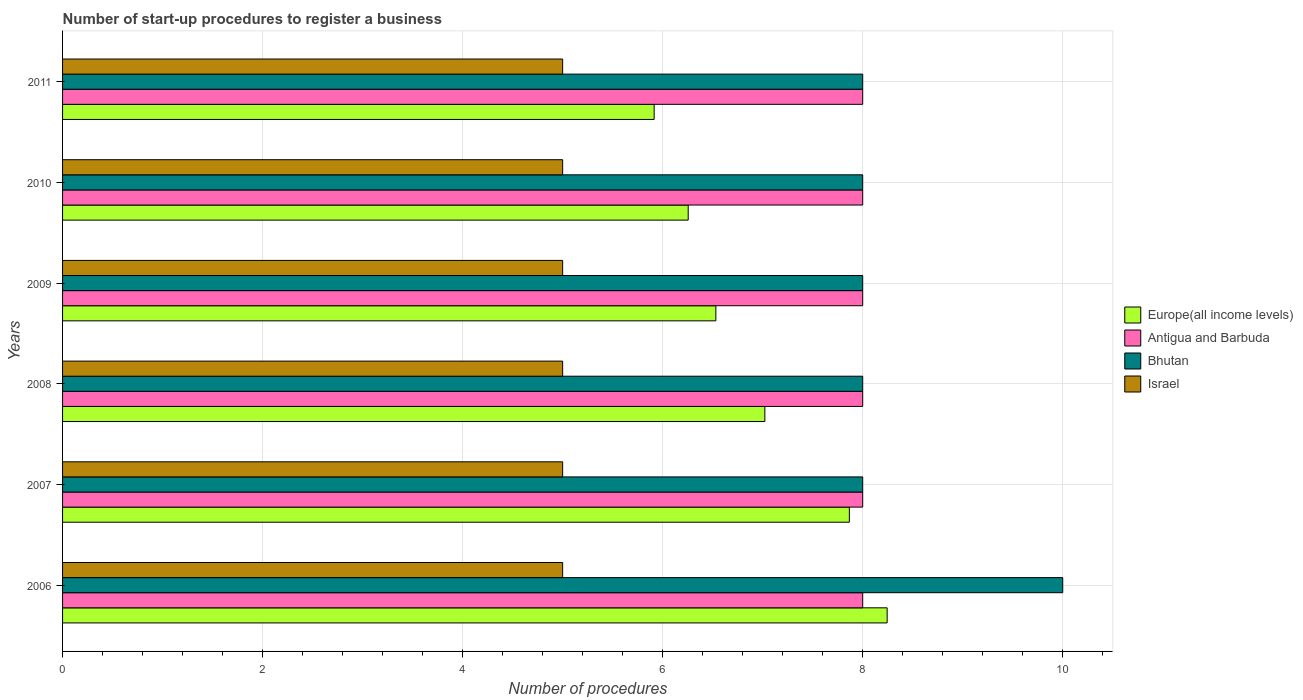How many different coloured bars are there?
Offer a very short reply. 4. How many groups of bars are there?
Your response must be concise. 6. Are the number of bars per tick equal to the number of legend labels?
Keep it short and to the point. Yes. Are the number of bars on each tick of the Y-axis equal?
Offer a terse response. Yes. What is the label of the 4th group of bars from the top?
Provide a succinct answer. 2008. What is the number of procedures required to register a business in Europe(all income levels) in 2011?
Your answer should be very brief. 5.91. Across all years, what is the maximum number of procedures required to register a business in Israel?
Provide a short and direct response. 5. Across all years, what is the minimum number of procedures required to register a business in Bhutan?
Provide a succinct answer. 8. In which year was the number of procedures required to register a business in Israel maximum?
Provide a succinct answer. 2006. What is the total number of procedures required to register a business in Antigua and Barbuda in the graph?
Keep it short and to the point. 48. What is the difference between the number of procedures required to register a business in Bhutan in 2006 and that in 2011?
Your response must be concise. 2. What is the difference between the number of procedures required to register a business in Israel in 2009 and the number of procedures required to register a business in Antigua and Barbuda in 2011?
Offer a very short reply. -3. What is the average number of procedures required to register a business in Antigua and Barbuda per year?
Keep it short and to the point. 8. In the year 2007, what is the difference between the number of procedures required to register a business in Europe(all income levels) and number of procedures required to register a business in Israel?
Ensure brevity in your answer.  2.87. In how many years, is the number of procedures required to register a business in Bhutan greater than 6 ?
Your answer should be very brief. 6. What is the ratio of the number of procedures required to register a business in Bhutan in 2007 to that in 2008?
Keep it short and to the point. 1. Is the number of procedures required to register a business in Antigua and Barbuda in 2007 less than that in 2008?
Your answer should be very brief. No. What is the difference between the highest and the lowest number of procedures required to register a business in Israel?
Offer a terse response. 0. Is the sum of the number of procedures required to register a business in Bhutan in 2010 and 2011 greater than the maximum number of procedures required to register a business in Europe(all income levels) across all years?
Your answer should be compact. Yes. Is it the case that in every year, the sum of the number of procedures required to register a business in Bhutan and number of procedures required to register a business in Israel is greater than the sum of number of procedures required to register a business in Europe(all income levels) and number of procedures required to register a business in Antigua and Barbuda?
Keep it short and to the point. Yes. What does the 4th bar from the top in 2009 represents?
Your answer should be very brief. Europe(all income levels). What does the 4th bar from the bottom in 2007 represents?
Provide a succinct answer. Israel. Is it the case that in every year, the sum of the number of procedures required to register a business in Europe(all income levels) and number of procedures required to register a business in Antigua and Barbuda is greater than the number of procedures required to register a business in Israel?
Give a very brief answer. Yes. How many bars are there?
Offer a very short reply. 24. Are all the bars in the graph horizontal?
Your answer should be very brief. Yes. Are the values on the major ticks of X-axis written in scientific E-notation?
Keep it short and to the point. No. Does the graph contain grids?
Make the answer very short. Yes. How many legend labels are there?
Offer a terse response. 4. How are the legend labels stacked?
Your response must be concise. Vertical. What is the title of the graph?
Provide a succinct answer. Number of start-up procedures to register a business. What is the label or title of the X-axis?
Make the answer very short. Number of procedures. What is the Number of procedures in Europe(all income levels) in 2006?
Your response must be concise. 8.24. What is the Number of procedures in Antigua and Barbuda in 2006?
Your answer should be compact. 8. What is the Number of procedures of Bhutan in 2006?
Offer a terse response. 10. What is the Number of procedures of Europe(all income levels) in 2007?
Give a very brief answer. 7.87. What is the Number of procedures of Antigua and Barbuda in 2007?
Make the answer very short. 8. What is the Number of procedures in Bhutan in 2007?
Offer a very short reply. 8. What is the Number of procedures of Europe(all income levels) in 2008?
Your answer should be very brief. 7.02. What is the Number of procedures in Antigua and Barbuda in 2008?
Provide a short and direct response. 8. What is the Number of procedures in Bhutan in 2008?
Ensure brevity in your answer.  8. What is the Number of procedures of Israel in 2008?
Your answer should be very brief. 5. What is the Number of procedures of Europe(all income levels) in 2009?
Ensure brevity in your answer.  6.53. What is the Number of procedures in Europe(all income levels) in 2010?
Your answer should be compact. 6.26. What is the Number of procedures of Antigua and Barbuda in 2010?
Your answer should be very brief. 8. What is the Number of procedures of Europe(all income levels) in 2011?
Provide a succinct answer. 5.91. What is the Number of procedures in Antigua and Barbuda in 2011?
Offer a terse response. 8. What is the Number of procedures in Israel in 2011?
Offer a terse response. 5. Across all years, what is the maximum Number of procedures in Europe(all income levels)?
Provide a short and direct response. 8.24. Across all years, what is the minimum Number of procedures in Europe(all income levels)?
Provide a succinct answer. 5.91. Across all years, what is the minimum Number of procedures of Bhutan?
Your answer should be compact. 8. What is the total Number of procedures of Europe(all income levels) in the graph?
Make the answer very short. 41.84. What is the total Number of procedures in Antigua and Barbuda in the graph?
Offer a terse response. 48. What is the total Number of procedures of Bhutan in the graph?
Give a very brief answer. 50. What is the total Number of procedures of Israel in the graph?
Offer a very short reply. 30. What is the difference between the Number of procedures in Europe(all income levels) in 2006 and that in 2007?
Offer a terse response. 0.38. What is the difference between the Number of procedures in Antigua and Barbuda in 2006 and that in 2007?
Make the answer very short. 0. What is the difference between the Number of procedures in Israel in 2006 and that in 2007?
Offer a terse response. 0. What is the difference between the Number of procedures of Europe(all income levels) in 2006 and that in 2008?
Your response must be concise. 1.22. What is the difference between the Number of procedures of Antigua and Barbuda in 2006 and that in 2008?
Provide a succinct answer. 0. What is the difference between the Number of procedures of Bhutan in 2006 and that in 2008?
Ensure brevity in your answer.  2. What is the difference between the Number of procedures of Israel in 2006 and that in 2008?
Keep it short and to the point. 0. What is the difference between the Number of procedures of Europe(all income levels) in 2006 and that in 2009?
Provide a short and direct response. 1.71. What is the difference between the Number of procedures of Europe(all income levels) in 2006 and that in 2010?
Ensure brevity in your answer.  1.99. What is the difference between the Number of procedures in Antigua and Barbuda in 2006 and that in 2010?
Keep it short and to the point. 0. What is the difference between the Number of procedures of Israel in 2006 and that in 2010?
Your answer should be very brief. 0. What is the difference between the Number of procedures of Europe(all income levels) in 2006 and that in 2011?
Provide a succinct answer. 2.33. What is the difference between the Number of procedures of Antigua and Barbuda in 2006 and that in 2011?
Your response must be concise. 0. What is the difference between the Number of procedures in Israel in 2006 and that in 2011?
Provide a short and direct response. 0. What is the difference between the Number of procedures in Europe(all income levels) in 2007 and that in 2008?
Give a very brief answer. 0.84. What is the difference between the Number of procedures in Antigua and Barbuda in 2007 and that in 2008?
Offer a terse response. 0. What is the difference between the Number of procedures in Bhutan in 2007 and that in 2008?
Provide a short and direct response. 0. What is the difference between the Number of procedures in Europe(all income levels) in 2007 and that in 2009?
Provide a succinct answer. 1.33. What is the difference between the Number of procedures in Antigua and Barbuda in 2007 and that in 2009?
Make the answer very short. 0. What is the difference between the Number of procedures of Bhutan in 2007 and that in 2009?
Your response must be concise. 0. What is the difference between the Number of procedures of Israel in 2007 and that in 2009?
Provide a short and direct response. 0. What is the difference between the Number of procedures of Europe(all income levels) in 2007 and that in 2010?
Your answer should be very brief. 1.61. What is the difference between the Number of procedures in Antigua and Barbuda in 2007 and that in 2010?
Your answer should be very brief. 0. What is the difference between the Number of procedures in Israel in 2007 and that in 2010?
Your answer should be very brief. 0. What is the difference between the Number of procedures of Europe(all income levels) in 2007 and that in 2011?
Your response must be concise. 1.95. What is the difference between the Number of procedures in Antigua and Barbuda in 2007 and that in 2011?
Keep it short and to the point. 0. What is the difference between the Number of procedures of Bhutan in 2007 and that in 2011?
Make the answer very short. 0. What is the difference between the Number of procedures in Europe(all income levels) in 2008 and that in 2009?
Keep it short and to the point. 0.49. What is the difference between the Number of procedures in Israel in 2008 and that in 2009?
Offer a very short reply. 0. What is the difference between the Number of procedures in Europe(all income levels) in 2008 and that in 2010?
Offer a very short reply. 0.77. What is the difference between the Number of procedures in Antigua and Barbuda in 2008 and that in 2010?
Ensure brevity in your answer.  0. What is the difference between the Number of procedures in Bhutan in 2008 and that in 2010?
Make the answer very short. 0. What is the difference between the Number of procedures of Israel in 2008 and that in 2010?
Give a very brief answer. 0. What is the difference between the Number of procedures of Europe(all income levels) in 2008 and that in 2011?
Ensure brevity in your answer.  1.11. What is the difference between the Number of procedures in Israel in 2008 and that in 2011?
Make the answer very short. 0. What is the difference between the Number of procedures in Europe(all income levels) in 2009 and that in 2010?
Your response must be concise. 0.28. What is the difference between the Number of procedures in Antigua and Barbuda in 2009 and that in 2010?
Your answer should be compact. 0. What is the difference between the Number of procedures of Europe(all income levels) in 2009 and that in 2011?
Make the answer very short. 0.62. What is the difference between the Number of procedures of Antigua and Barbuda in 2009 and that in 2011?
Offer a terse response. 0. What is the difference between the Number of procedures in Israel in 2009 and that in 2011?
Offer a very short reply. 0. What is the difference between the Number of procedures in Europe(all income levels) in 2010 and that in 2011?
Your answer should be very brief. 0.34. What is the difference between the Number of procedures of Antigua and Barbuda in 2010 and that in 2011?
Ensure brevity in your answer.  0. What is the difference between the Number of procedures in Bhutan in 2010 and that in 2011?
Your answer should be compact. 0. What is the difference between the Number of procedures in Europe(all income levels) in 2006 and the Number of procedures in Antigua and Barbuda in 2007?
Offer a terse response. 0.24. What is the difference between the Number of procedures of Europe(all income levels) in 2006 and the Number of procedures of Bhutan in 2007?
Make the answer very short. 0.24. What is the difference between the Number of procedures of Europe(all income levels) in 2006 and the Number of procedures of Israel in 2007?
Ensure brevity in your answer.  3.24. What is the difference between the Number of procedures in Antigua and Barbuda in 2006 and the Number of procedures in Israel in 2007?
Your answer should be very brief. 3. What is the difference between the Number of procedures of Bhutan in 2006 and the Number of procedures of Israel in 2007?
Your response must be concise. 5. What is the difference between the Number of procedures in Europe(all income levels) in 2006 and the Number of procedures in Antigua and Barbuda in 2008?
Ensure brevity in your answer.  0.24. What is the difference between the Number of procedures of Europe(all income levels) in 2006 and the Number of procedures of Bhutan in 2008?
Give a very brief answer. 0.24. What is the difference between the Number of procedures of Europe(all income levels) in 2006 and the Number of procedures of Israel in 2008?
Give a very brief answer. 3.24. What is the difference between the Number of procedures of Europe(all income levels) in 2006 and the Number of procedures of Antigua and Barbuda in 2009?
Provide a succinct answer. 0.24. What is the difference between the Number of procedures in Europe(all income levels) in 2006 and the Number of procedures in Bhutan in 2009?
Provide a short and direct response. 0.24. What is the difference between the Number of procedures in Europe(all income levels) in 2006 and the Number of procedures in Israel in 2009?
Give a very brief answer. 3.24. What is the difference between the Number of procedures of Antigua and Barbuda in 2006 and the Number of procedures of Bhutan in 2009?
Give a very brief answer. 0. What is the difference between the Number of procedures in Bhutan in 2006 and the Number of procedures in Israel in 2009?
Make the answer very short. 5. What is the difference between the Number of procedures in Europe(all income levels) in 2006 and the Number of procedures in Antigua and Barbuda in 2010?
Make the answer very short. 0.24. What is the difference between the Number of procedures of Europe(all income levels) in 2006 and the Number of procedures of Bhutan in 2010?
Provide a succinct answer. 0.24. What is the difference between the Number of procedures in Europe(all income levels) in 2006 and the Number of procedures in Israel in 2010?
Your response must be concise. 3.24. What is the difference between the Number of procedures in Antigua and Barbuda in 2006 and the Number of procedures in Israel in 2010?
Provide a short and direct response. 3. What is the difference between the Number of procedures in Bhutan in 2006 and the Number of procedures in Israel in 2010?
Offer a terse response. 5. What is the difference between the Number of procedures in Europe(all income levels) in 2006 and the Number of procedures in Antigua and Barbuda in 2011?
Keep it short and to the point. 0.24. What is the difference between the Number of procedures of Europe(all income levels) in 2006 and the Number of procedures of Bhutan in 2011?
Give a very brief answer. 0.24. What is the difference between the Number of procedures in Europe(all income levels) in 2006 and the Number of procedures in Israel in 2011?
Give a very brief answer. 3.24. What is the difference between the Number of procedures of Europe(all income levels) in 2007 and the Number of procedures of Antigua and Barbuda in 2008?
Provide a short and direct response. -0.13. What is the difference between the Number of procedures of Europe(all income levels) in 2007 and the Number of procedures of Bhutan in 2008?
Your answer should be compact. -0.13. What is the difference between the Number of procedures of Europe(all income levels) in 2007 and the Number of procedures of Israel in 2008?
Provide a succinct answer. 2.87. What is the difference between the Number of procedures of Europe(all income levels) in 2007 and the Number of procedures of Antigua and Barbuda in 2009?
Make the answer very short. -0.13. What is the difference between the Number of procedures in Europe(all income levels) in 2007 and the Number of procedures in Bhutan in 2009?
Your response must be concise. -0.13. What is the difference between the Number of procedures in Europe(all income levels) in 2007 and the Number of procedures in Israel in 2009?
Offer a very short reply. 2.87. What is the difference between the Number of procedures in Antigua and Barbuda in 2007 and the Number of procedures in Bhutan in 2009?
Offer a very short reply. 0. What is the difference between the Number of procedures in Europe(all income levels) in 2007 and the Number of procedures in Antigua and Barbuda in 2010?
Make the answer very short. -0.13. What is the difference between the Number of procedures of Europe(all income levels) in 2007 and the Number of procedures of Bhutan in 2010?
Provide a short and direct response. -0.13. What is the difference between the Number of procedures of Europe(all income levels) in 2007 and the Number of procedures of Israel in 2010?
Make the answer very short. 2.87. What is the difference between the Number of procedures in Antigua and Barbuda in 2007 and the Number of procedures in Bhutan in 2010?
Offer a terse response. 0. What is the difference between the Number of procedures of Antigua and Barbuda in 2007 and the Number of procedures of Israel in 2010?
Keep it short and to the point. 3. What is the difference between the Number of procedures of Europe(all income levels) in 2007 and the Number of procedures of Antigua and Barbuda in 2011?
Your answer should be very brief. -0.13. What is the difference between the Number of procedures of Europe(all income levels) in 2007 and the Number of procedures of Bhutan in 2011?
Ensure brevity in your answer.  -0.13. What is the difference between the Number of procedures in Europe(all income levels) in 2007 and the Number of procedures in Israel in 2011?
Your answer should be compact. 2.87. What is the difference between the Number of procedures of Antigua and Barbuda in 2007 and the Number of procedures of Bhutan in 2011?
Your response must be concise. 0. What is the difference between the Number of procedures in Antigua and Barbuda in 2007 and the Number of procedures in Israel in 2011?
Your response must be concise. 3. What is the difference between the Number of procedures of Bhutan in 2007 and the Number of procedures of Israel in 2011?
Offer a very short reply. 3. What is the difference between the Number of procedures of Europe(all income levels) in 2008 and the Number of procedures of Antigua and Barbuda in 2009?
Offer a terse response. -0.98. What is the difference between the Number of procedures in Europe(all income levels) in 2008 and the Number of procedures in Bhutan in 2009?
Give a very brief answer. -0.98. What is the difference between the Number of procedures in Europe(all income levels) in 2008 and the Number of procedures in Israel in 2009?
Offer a very short reply. 2.02. What is the difference between the Number of procedures of Antigua and Barbuda in 2008 and the Number of procedures of Israel in 2009?
Provide a succinct answer. 3. What is the difference between the Number of procedures of Bhutan in 2008 and the Number of procedures of Israel in 2009?
Your response must be concise. 3. What is the difference between the Number of procedures of Europe(all income levels) in 2008 and the Number of procedures of Antigua and Barbuda in 2010?
Make the answer very short. -0.98. What is the difference between the Number of procedures in Europe(all income levels) in 2008 and the Number of procedures in Bhutan in 2010?
Give a very brief answer. -0.98. What is the difference between the Number of procedures of Europe(all income levels) in 2008 and the Number of procedures of Israel in 2010?
Make the answer very short. 2.02. What is the difference between the Number of procedures in Europe(all income levels) in 2008 and the Number of procedures in Antigua and Barbuda in 2011?
Offer a terse response. -0.98. What is the difference between the Number of procedures in Europe(all income levels) in 2008 and the Number of procedures in Bhutan in 2011?
Your answer should be compact. -0.98. What is the difference between the Number of procedures in Europe(all income levels) in 2008 and the Number of procedures in Israel in 2011?
Your response must be concise. 2.02. What is the difference between the Number of procedures of Antigua and Barbuda in 2008 and the Number of procedures of Bhutan in 2011?
Give a very brief answer. 0. What is the difference between the Number of procedures in Antigua and Barbuda in 2008 and the Number of procedures in Israel in 2011?
Offer a terse response. 3. What is the difference between the Number of procedures of Europe(all income levels) in 2009 and the Number of procedures of Antigua and Barbuda in 2010?
Your answer should be compact. -1.47. What is the difference between the Number of procedures in Europe(all income levels) in 2009 and the Number of procedures in Bhutan in 2010?
Provide a short and direct response. -1.47. What is the difference between the Number of procedures of Europe(all income levels) in 2009 and the Number of procedures of Israel in 2010?
Ensure brevity in your answer.  1.53. What is the difference between the Number of procedures of Antigua and Barbuda in 2009 and the Number of procedures of Bhutan in 2010?
Your answer should be very brief. 0. What is the difference between the Number of procedures of Bhutan in 2009 and the Number of procedures of Israel in 2010?
Your answer should be compact. 3. What is the difference between the Number of procedures in Europe(all income levels) in 2009 and the Number of procedures in Antigua and Barbuda in 2011?
Your answer should be compact. -1.47. What is the difference between the Number of procedures in Europe(all income levels) in 2009 and the Number of procedures in Bhutan in 2011?
Offer a terse response. -1.47. What is the difference between the Number of procedures in Europe(all income levels) in 2009 and the Number of procedures in Israel in 2011?
Give a very brief answer. 1.53. What is the difference between the Number of procedures in Antigua and Barbuda in 2009 and the Number of procedures in Bhutan in 2011?
Your response must be concise. 0. What is the difference between the Number of procedures of Bhutan in 2009 and the Number of procedures of Israel in 2011?
Provide a short and direct response. 3. What is the difference between the Number of procedures of Europe(all income levels) in 2010 and the Number of procedures of Antigua and Barbuda in 2011?
Ensure brevity in your answer.  -1.74. What is the difference between the Number of procedures of Europe(all income levels) in 2010 and the Number of procedures of Bhutan in 2011?
Your answer should be compact. -1.74. What is the difference between the Number of procedures in Europe(all income levels) in 2010 and the Number of procedures in Israel in 2011?
Ensure brevity in your answer.  1.26. What is the difference between the Number of procedures in Antigua and Barbuda in 2010 and the Number of procedures in Bhutan in 2011?
Your response must be concise. 0. What is the average Number of procedures of Europe(all income levels) per year?
Offer a terse response. 6.97. What is the average Number of procedures in Antigua and Barbuda per year?
Your answer should be very brief. 8. What is the average Number of procedures in Bhutan per year?
Give a very brief answer. 8.33. In the year 2006, what is the difference between the Number of procedures of Europe(all income levels) and Number of procedures of Antigua and Barbuda?
Your answer should be compact. 0.24. In the year 2006, what is the difference between the Number of procedures of Europe(all income levels) and Number of procedures of Bhutan?
Make the answer very short. -1.76. In the year 2006, what is the difference between the Number of procedures in Europe(all income levels) and Number of procedures in Israel?
Provide a short and direct response. 3.24. In the year 2006, what is the difference between the Number of procedures of Antigua and Barbuda and Number of procedures of Bhutan?
Provide a succinct answer. -2. In the year 2006, what is the difference between the Number of procedures of Bhutan and Number of procedures of Israel?
Provide a succinct answer. 5. In the year 2007, what is the difference between the Number of procedures of Europe(all income levels) and Number of procedures of Antigua and Barbuda?
Offer a very short reply. -0.13. In the year 2007, what is the difference between the Number of procedures in Europe(all income levels) and Number of procedures in Bhutan?
Give a very brief answer. -0.13. In the year 2007, what is the difference between the Number of procedures of Europe(all income levels) and Number of procedures of Israel?
Give a very brief answer. 2.87. In the year 2007, what is the difference between the Number of procedures in Bhutan and Number of procedures in Israel?
Provide a short and direct response. 3. In the year 2008, what is the difference between the Number of procedures in Europe(all income levels) and Number of procedures in Antigua and Barbuda?
Offer a terse response. -0.98. In the year 2008, what is the difference between the Number of procedures of Europe(all income levels) and Number of procedures of Bhutan?
Keep it short and to the point. -0.98. In the year 2008, what is the difference between the Number of procedures of Europe(all income levels) and Number of procedures of Israel?
Keep it short and to the point. 2.02. In the year 2008, what is the difference between the Number of procedures of Antigua and Barbuda and Number of procedures of Israel?
Keep it short and to the point. 3. In the year 2009, what is the difference between the Number of procedures in Europe(all income levels) and Number of procedures in Antigua and Barbuda?
Offer a very short reply. -1.47. In the year 2009, what is the difference between the Number of procedures of Europe(all income levels) and Number of procedures of Bhutan?
Make the answer very short. -1.47. In the year 2009, what is the difference between the Number of procedures of Europe(all income levels) and Number of procedures of Israel?
Ensure brevity in your answer.  1.53. In the year 2009, what is the difference between the Number of procedures in Antigua and Barbuda and Number of procedures in Bhutan?
Your answer should be compact. 0. In the year 2009, what is the difference between the Number of procedures in Antigua and Barbuda and Number of procedures in Israel?
Make the answer very short. 3. In the year 2010, what is the difference between the Number of procedures in Europe(all income levels) and Number of procedures in Antigua and Barbuda?
Offer a terse response. -1.74. In the year 2010, what is the difference between the Number of procedures in Europe(all income levels) and Number of procedures in Bhutan?
Give a very brief answer. -1.74. In the year 2010, what is the difference between the Number of procedures in Europe(all income levels) and Number of procedures in Israel?
Make the answer very short. 1.26. In the year 2010, what is the difference between the Number of procedures of Antigua and Barbuda and Number of procedures of Bhutan?
Your response must be concise. 0. In the year 2010, what is the difference between the Number of procedures of Antigua and Barbuda and Number of procedures of Israel?
Offer a very short reply. 3. In the year 2010, what is the difference between the Number of procedures in Bhutan and Number of procedures in Israel?
Your answer should be compact. 3. In the year 2011, what is the difference between the Number of procedures in Europe(all income levels) and Number of procedures in Antigua and Barbuda?
Give a very brief answer. -2.09. In the year 2011, what is the difference between the Number of procedures in Europe(all income levels) and Number of procedures in Bhutan?
Provide a succinct answer. -2.09. In the year 2011, what is the difference between the Number of procedures in Europe(all income levels) and Number of procedures in Israel?
Your answer should be very brief. 0.91. In the year 2011, what is the difference between the Number of procedures in Antigua and Barbuda and Number of procedures in Bhutan?
Give a very brief answer. 0. In the year 2011, what is the difference between the Number of procedures in Antigua and Barbuda and Number of procedures in Israel?
Ensure brevity in your answer.  3. In the year 2011, what is the difference between the Number of procedures in Bhutan and Number of procedures in Israel?
Your answer should be very brief. 3. What is the ratio of the Number of procedures in Europe(all income levels) in 2006 to that in 2007?
Ensure brevity in your answer.  1.05. What is the ratio of the Number of procedures of Europe(all income levels) in 2006 to that in 2008?
Make the answer very short. 1.17. What is the ratio of the Number of procedures of Antigua and Barbuda in 2006 to that in 2008?
Keep it short and to the point. 1. What is the ratio of the Number of procedures of Bhutan in 2006 to that in 2008?
Make the answer very short. 1.25. What is the ratio of the Number of procedures in Europe(all income levels) in 2006 to that in 2009?
Give a very brief answer. 1.26. What is the ratio of the Number of procedures of Antigua and Barbuda in 2006 to that in 2009?
Your answer should be compact. 1. What is the ratio of the Number of procedures of Bhutan in 2006 to that in 2009?
Your answer should be very brief. 1.25. What is the ratio of the Number of procedures of Europe(all income levels) in 2006 to that in 2010?
Keep it short and to the point. 1.32. What is the ratio of the Number of procedures of Bhutan in 2006 to that in 2010?
Provide a succinct answer. 1.25. What is the ratio of the Number of procedures in Israel in 2006 to that in 2010?
Provide a short and direct response. 1. What is the ratio of the Number of procedures in Europe(all income levels) in 2006 to that in 2011?
Provide a short and direct response. 1.39. What is the ratio of the Number of procedures in Antigua and Barbuda in 2006 to that in 2011?
Provide a succinct answer. 1. What is the ratio of the Number of procedures of Bhutan in 2006 to that in 2011?
Offer a very short reply. 1.25. What is the ratio of the Number of procedures in Israel in 2006 to that in 2011?
Offer a very short reply. 1. What is the ratio of the Number of procedures of Europe(all income levels) in 2007 to that in 2008?
Offer a very short reply. 1.12. What is the ratio of the Number of procedures in Antigua and Barbuda in 2007 to that in 2008?
Ensure brevity in your answer.  1. What is the ratio of the Number of procedures of Bhutan in 2007 to that in 2008?
Give a very brief answer. 1. What is the ratio of the Number of procedures of Israel in 2007 to that in 2008?
Provide a succinct answer. 1. What is the ratio of the Number of procedures in Europe(all income levels) in 2007 to that in 2009?
Provide a succinct answer. 1.2. What is the ratio of the Number of procedures in Antigua and Barbuda in 2007 to that in 2009?
Keep it short and to the point. 1. What is the ratio of the Number of procedures of Bhutan in 2007 to that in 2009?
Make the answer very short. 1. What is the ratio of the Number of procedures in Europe(all income levels) in 2007 to that in 2010?
Offer a terse response. 1.26. What is the ratio of the Number of procedures in Antigua and Barbuda in 2007 to that in 2010?
Make the answer very short. 1. What is the ratio of the Number of procedures in Europe(all income levels) in 2007 to that in 2011?
Give a very brief answer. 1.33. What is the ratio of the Number of procedures of Antigua and Barbuda in 2007 to that in 2011?
Ensure brevity in your answer.  1. What is the ratio of the Number of procedures in Bhutan in 2007 to that in 2011?
Provide a succinct answer. 1. What is the ratio of the Number of procedures in Israel in 2007 to that in 2011?
Provide a short and direct response. 1. What is the ratio of the Number of procedures in Europe(all income levels) in 2008 to that in 2009?
Give a very brief answer. 1.07. What is the ratio of the Number of procedures in Antigua and Barbuda in 2008 to that in 2009?
Keep it short and to the point. 1. What is the ratio of the Number of procedures of Bhutan in 2008 to that in 2009?
Provide a succinct answer. 1. What is the ratio of the Number of procedures of Europe(all income levels) in 2008 to that in 2010?
Provide a short and direct response. 1.12. What is the ratio of the Number of procedures in Bhutan in 2008 to that in 2010?
Provide a succinct answer. 1. What is the ratio of the Number of procedures of Europe(all income levels) in 2008 to that in 2011?
Your response must be concise. 1.19. What is the ratio of the Number of procedures in Antigua and Barbuda in 2008 to that in 2011?
Make the answer very short. 1. What is the ratio of the Number of procedures in Bhutan in 2008 to that in 2011?
Keep it short and to the point. 1. What is the ratio of the Number of procedures of Europe(all income levels) in 2009 to that in 2010?
Provide a succinct answer. 1.04. What is the ratio of the Number of procedures of Antigua and Barbuda in 2009 to that in 2010?
Offer a terse response. 1. What is the ratio of the Number of procedures in Bhutan in 2009 to that in 2010?
Offer a very short reply. 1. What is the ratio of the Number of procedures in Israel in 2009 to that in 2010?
Ensure brevity in your answer.  1. What is the ratio of the Number of procedures of Europe(all income levels) in 2009 to that in 2011?
Make the answer very short. 1.1. What is the ratio of the Number of procedures of Bhutan in 2009 to that in 2011?
Offer a terse response. 1. What is the ratio of the Number of procedures of Israel in 2009 to that in 2011?
Your answer should be very brief. 1. What is the ratio of the Number of procedures of Europe(all income levels) in 2010 to that in 2011?
Give a very brief answer. 1.06. What is the ratio of the Number of procedures of Israel in 2010 to that in 2011?
Ensure brevity in your answer.  1. What is the difference between the highest and the second highest Number of procedures in Europe(all income levels)?
Your answer should be compact. 0.38. What is the difference between the highest and the second highest Number of procedures of Antigua and Barbuda?
Make the answer very short. 0. What is the difference between the highest and the second highest Number of procedures in Bhutan?
Offer a terse response. 2. What is the difference between the highest and the lowest Number of procedures in Europe(all income levels)?
Offer a terse response. 2.33. What is the difference between the highest and the lowest Number of procedures of Bhutan?
Provide a short and direct response. 2. 